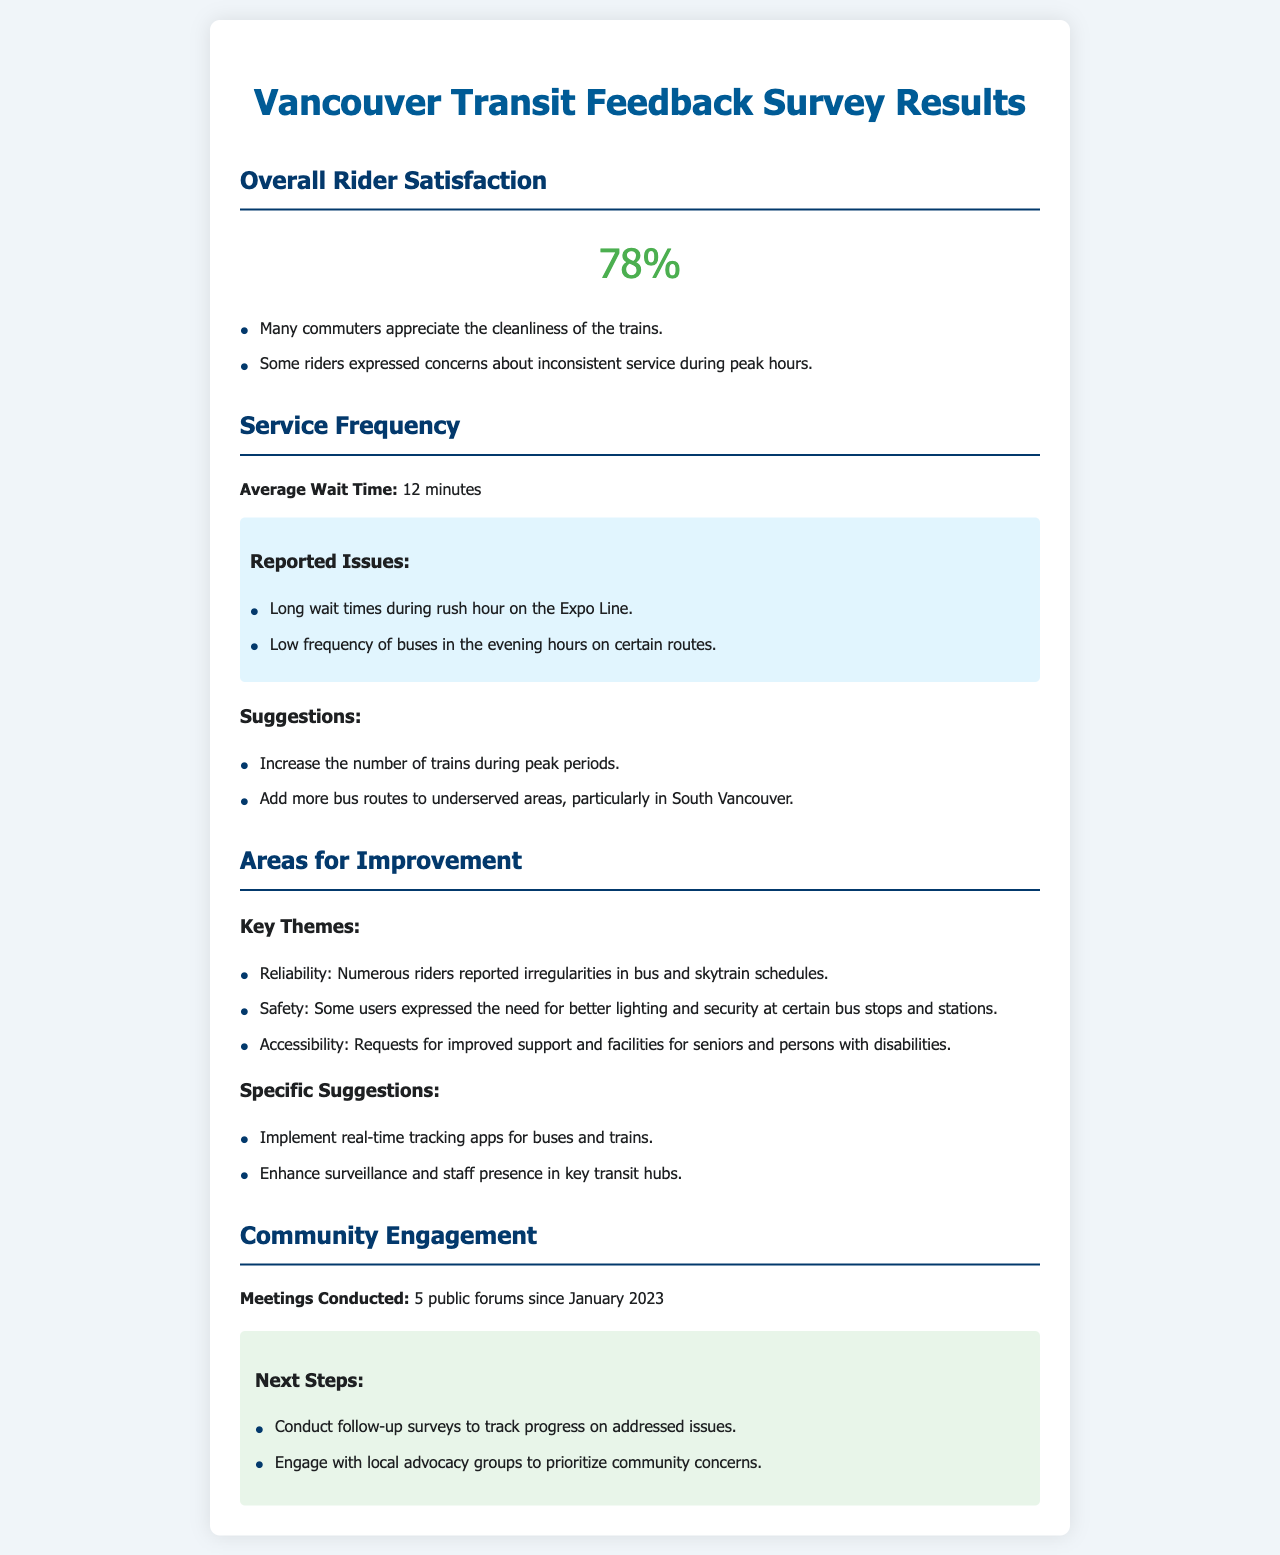what is the overall rider satisfaction percentage? The overall rider satisfaction percentage is directly mentioned at the top of the section on rider satisfaction.
Answer: 78% what is the average wait time reported in the survey? The average wait time is specifically stated in the service frequency section of the document.
Answer: 12 minutes what key issue is mentioned regarding the Expo Line? One specific issue related to the Expo Line is detailed in the reported issues under service frequency.
Answer: Long wait times during rush hour how many public forums have been conducted since January 2023? The number of public forums is listed under the community engagement section of the document.
Answer: 5 what theme emphasizes the need for better lighting? The theme related to lighting is highlighted under the areas for improvement section.
Answer: Safety what suggestion is made to support real-time tracking? The suggestion for real-time tracking is addressed in the specific suggestions section.
Answer: Implement real-time tracking apps for buses and trains what is one requested improvement for accessibility? The requests for improved accessibility are listed under the areas for improvement section of the document.
Answer: Improved support and facilities for seniors and persons with disabilities which group should be engaged to prioritize community concerns? The document specifies a group to engage for prioritizing concerns in the next steps section.
Answer: Local advocacy groups 